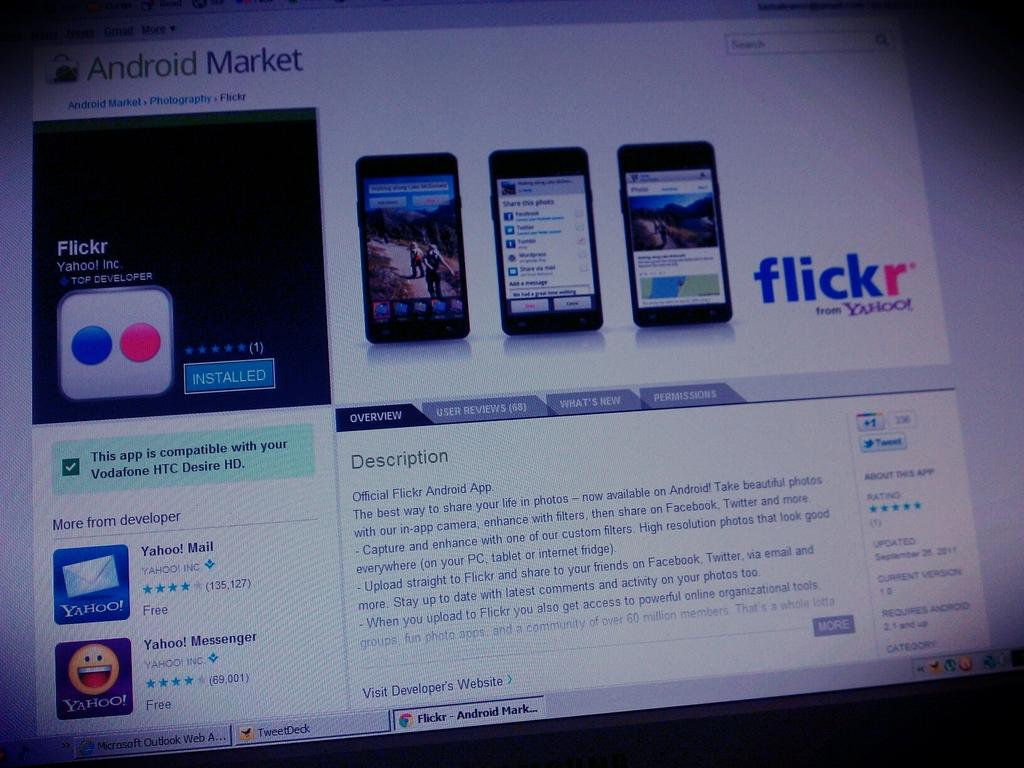What is the main subject of the image? The main subject of the image is a screenshot. What can be seen within the screenshot? The screenshot contains three mobile phones. Has the text in the screenshot been altered in any way? Yes, the text in the screenshot has been edited. What else is visible within the screenshot besides the mobile phones and edited text? There are icons present in the screenshot. What is the chance of winning a lottery in the image? There is no mention of a lottery or any chance of winning in the image. 